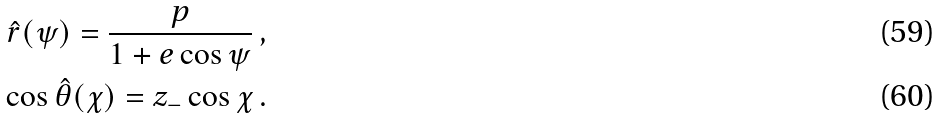Convert formula to latex. <formula><loc_0><loc_0><loc_500><loc_500>\hat { r } ( \psi ) = \frac { p } { 1 + e \cos \psi } \, , \\ \cos \hat { \theta } ( \chi ) = z _ { - } \cos \chi \, .</formula> 